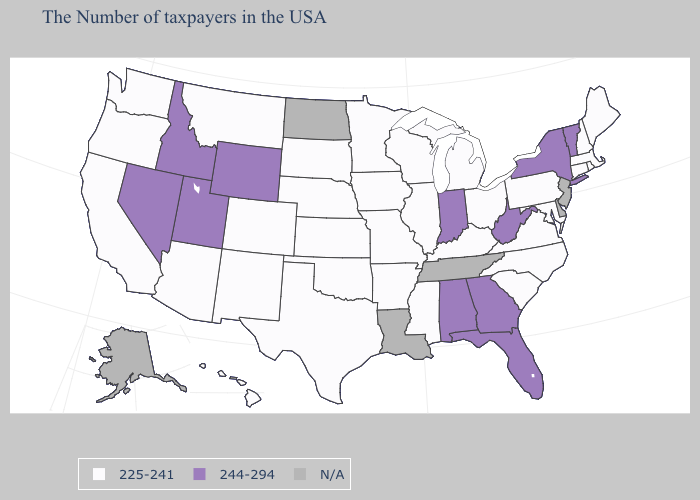Name the states that have a value in the range N/A?
Write a very short answer. New Jersey, Delaware, Tennessee, Louisiana, North Dakota, Alaska. Name the states that have a value in the range 225-241?
Answer briefly. Maine, Massachusetts, Rhode Island, New Hampshire, Connecticut, Maryland, Pennsylvania, Virginia, North Carolina, South Carolina, Ohio, Michigan, Kentucky, Wisconsin, Illinois, Mississippi, Missouri, Arkansas, Minnesota, Iowa, Kansas, Nebraska, Oklahoma, Texas, South Dakota, Colorado, New Mexico, Montana, Arizona, California, Washington, Oregon, Hawaii. Name the states that have a value in the range N/A?
Quick response, please. New Jersey, Delaware, Tennessee, Louisiana, North Dakota, Alaska. Name the states that have a value in the range 225-241?
Answer briefly. Maine, Massachusetts, Rhode Island, New Hampshire, Connecticut, Maryland, Pennsylvania, Virginia, North Carolina, South Carolina, Ohio, Michigan, Kentucky, Wisconsin, Illinois, Mississippi, Missouri, Arkansas, Minnesota, Iowa, Kansas, Nebraska, Oklahoma, Texas, South Dakota, Colorado, New Mexico, Montana, Arizona, California, Washington, Oregon, Hawaii. Which states have the lowest value in the South?
Answer briefly. Maryland, Virginia, North Carolina, South Carolina, Kentucky, Mississippi, Arkansas, Oklahoma, Texas. What is the highest value in the USA?
Be succinct. 244-294. What is the value of Connecticut?
Give a very brief answer. 225-241. Does New York have the lowest value in the Northeast?
Quick response, please. No. What is the value of Kansas?
Answer briefly. 225-241. What is the value of South Carolina?
Concise answer only. 225-241. What is the lowest value in states that border Florida?
Answer briefly. 244-294. 